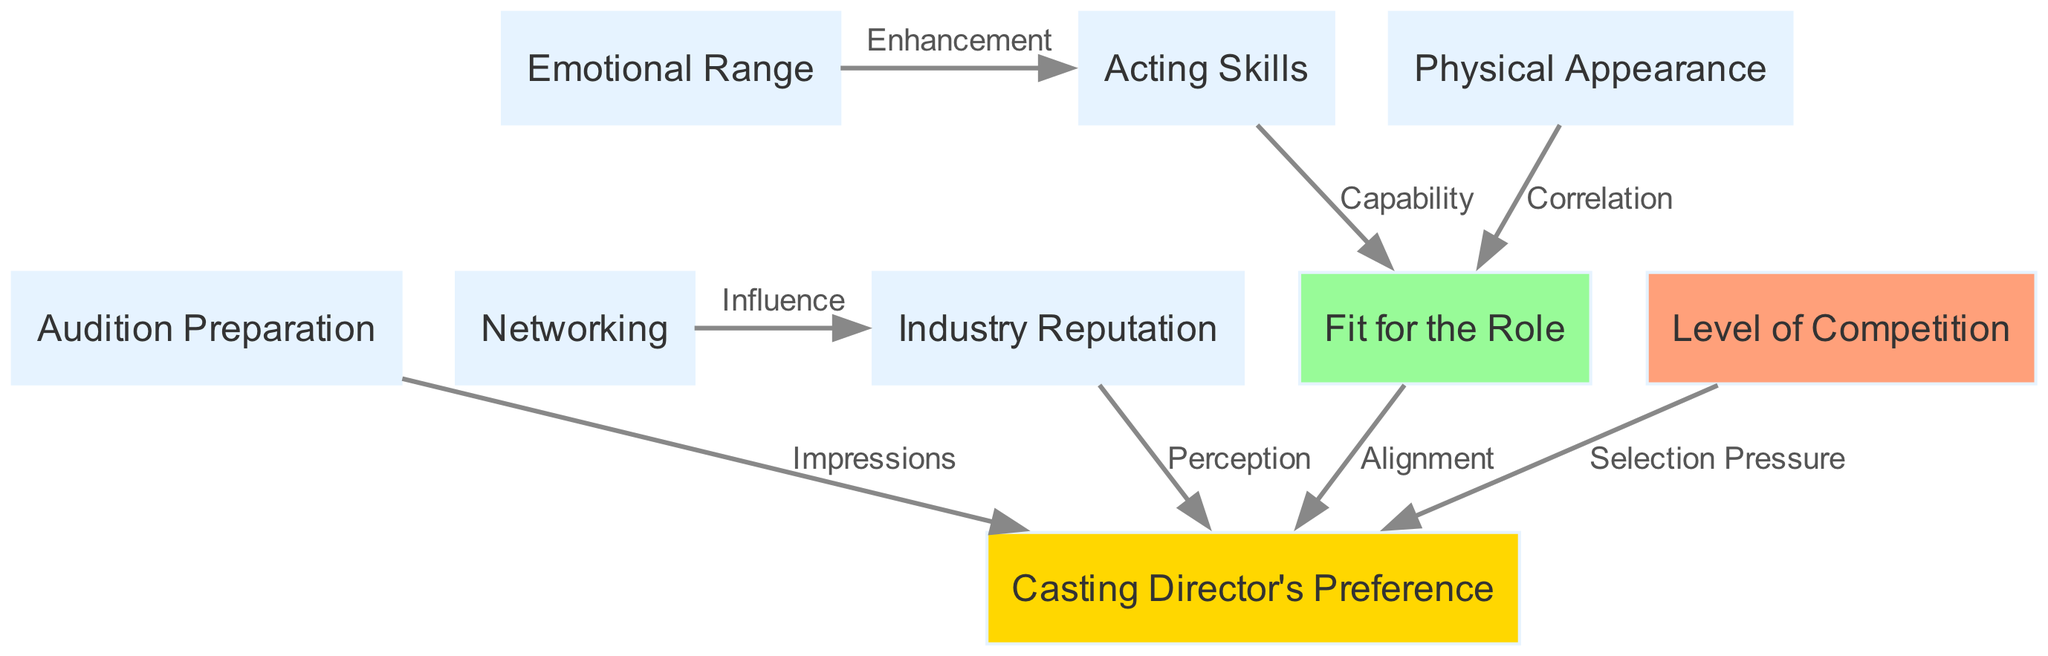What are the main factors influencing casting decisions? The main factors identified in the diagram are audition preparation, acting skills, emotional range, physical appearance, networking, industry reputation, fit for the role, casting director's preference, and level of competition.
Answer: audition preparation, acting skills, emotional range, physical appearance, networking, industry reputation, fit for the role, casting director's preference, level of competition How many nodes are in the diagram? The diagram includes nine nodes, which represent different factors influencing audition success rates.
Answer: 9 What is the relationship between acting skills and role fitness? The diagram indicates that acting skills have a direct influence on role fitness, as depicted by the 'Capability' edge connecting these two nodes.
Answer: Capability Which factor correlates with physical appearance? The diagram shows that physical appearance correlates with role fitness, as indicated by the edge labeled 'Correlation.'
Answer: Role Fitness What influences the casting director's preference apart from audition preparation? The casting director's preference is also influenced by the industry reputation, fit for the role, and level of competition, as shown by the edges connecting these factors to the casting director.
Answer: Industry reputation, fit for the role, level of competition How does networking affect reputation? The diagram illustrates that networking positively influences reputation, which is depicted by the edge labeled 'Influence.'
Answer: Influence What is the significance of casting director's preference in the diagram? The casting director's preference is portrayed as a central factor influenced by multiple other factors like audition preparation, reputation, and competition, indicating its critical role in casting decisions.
Answer: Critical role Which factor has an alignment with the casting director? The factor that has an alignment with the casting director is role fitness, as shown by the edge labeled 'Alignment.'
Answer: Role Fitness What is the labeled edge indicating the impression made by audition preparation on the casting director? The edge indicating this impression is labeled 'Impressions,' showing how audition preparation impacts the casting director's view.
Answer: Impressions 